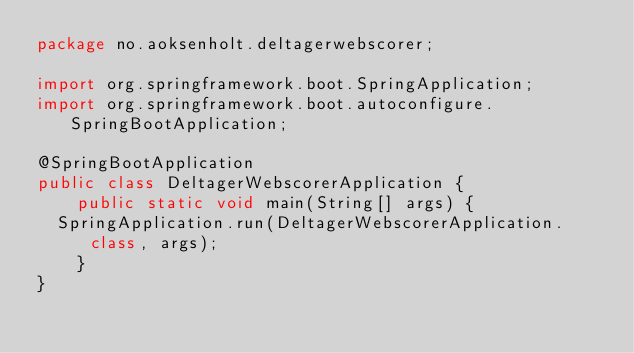<code> <loc_0><loc_0><loc_500><loc_500><_Java_>package no.aoksenholt.deltagerwebscorer;

import org.springframework.boot.SpringApplication;
import org.springframework.boot.autoconfigure.SpringBootApplication;

@SpringBootApplication
public class DeltagerWebscorerApplication {
    public static void main(String[] args) {
	SpringApplication.run(DeltagerWebscorerApplication.class, args);
    }
}
</code> 